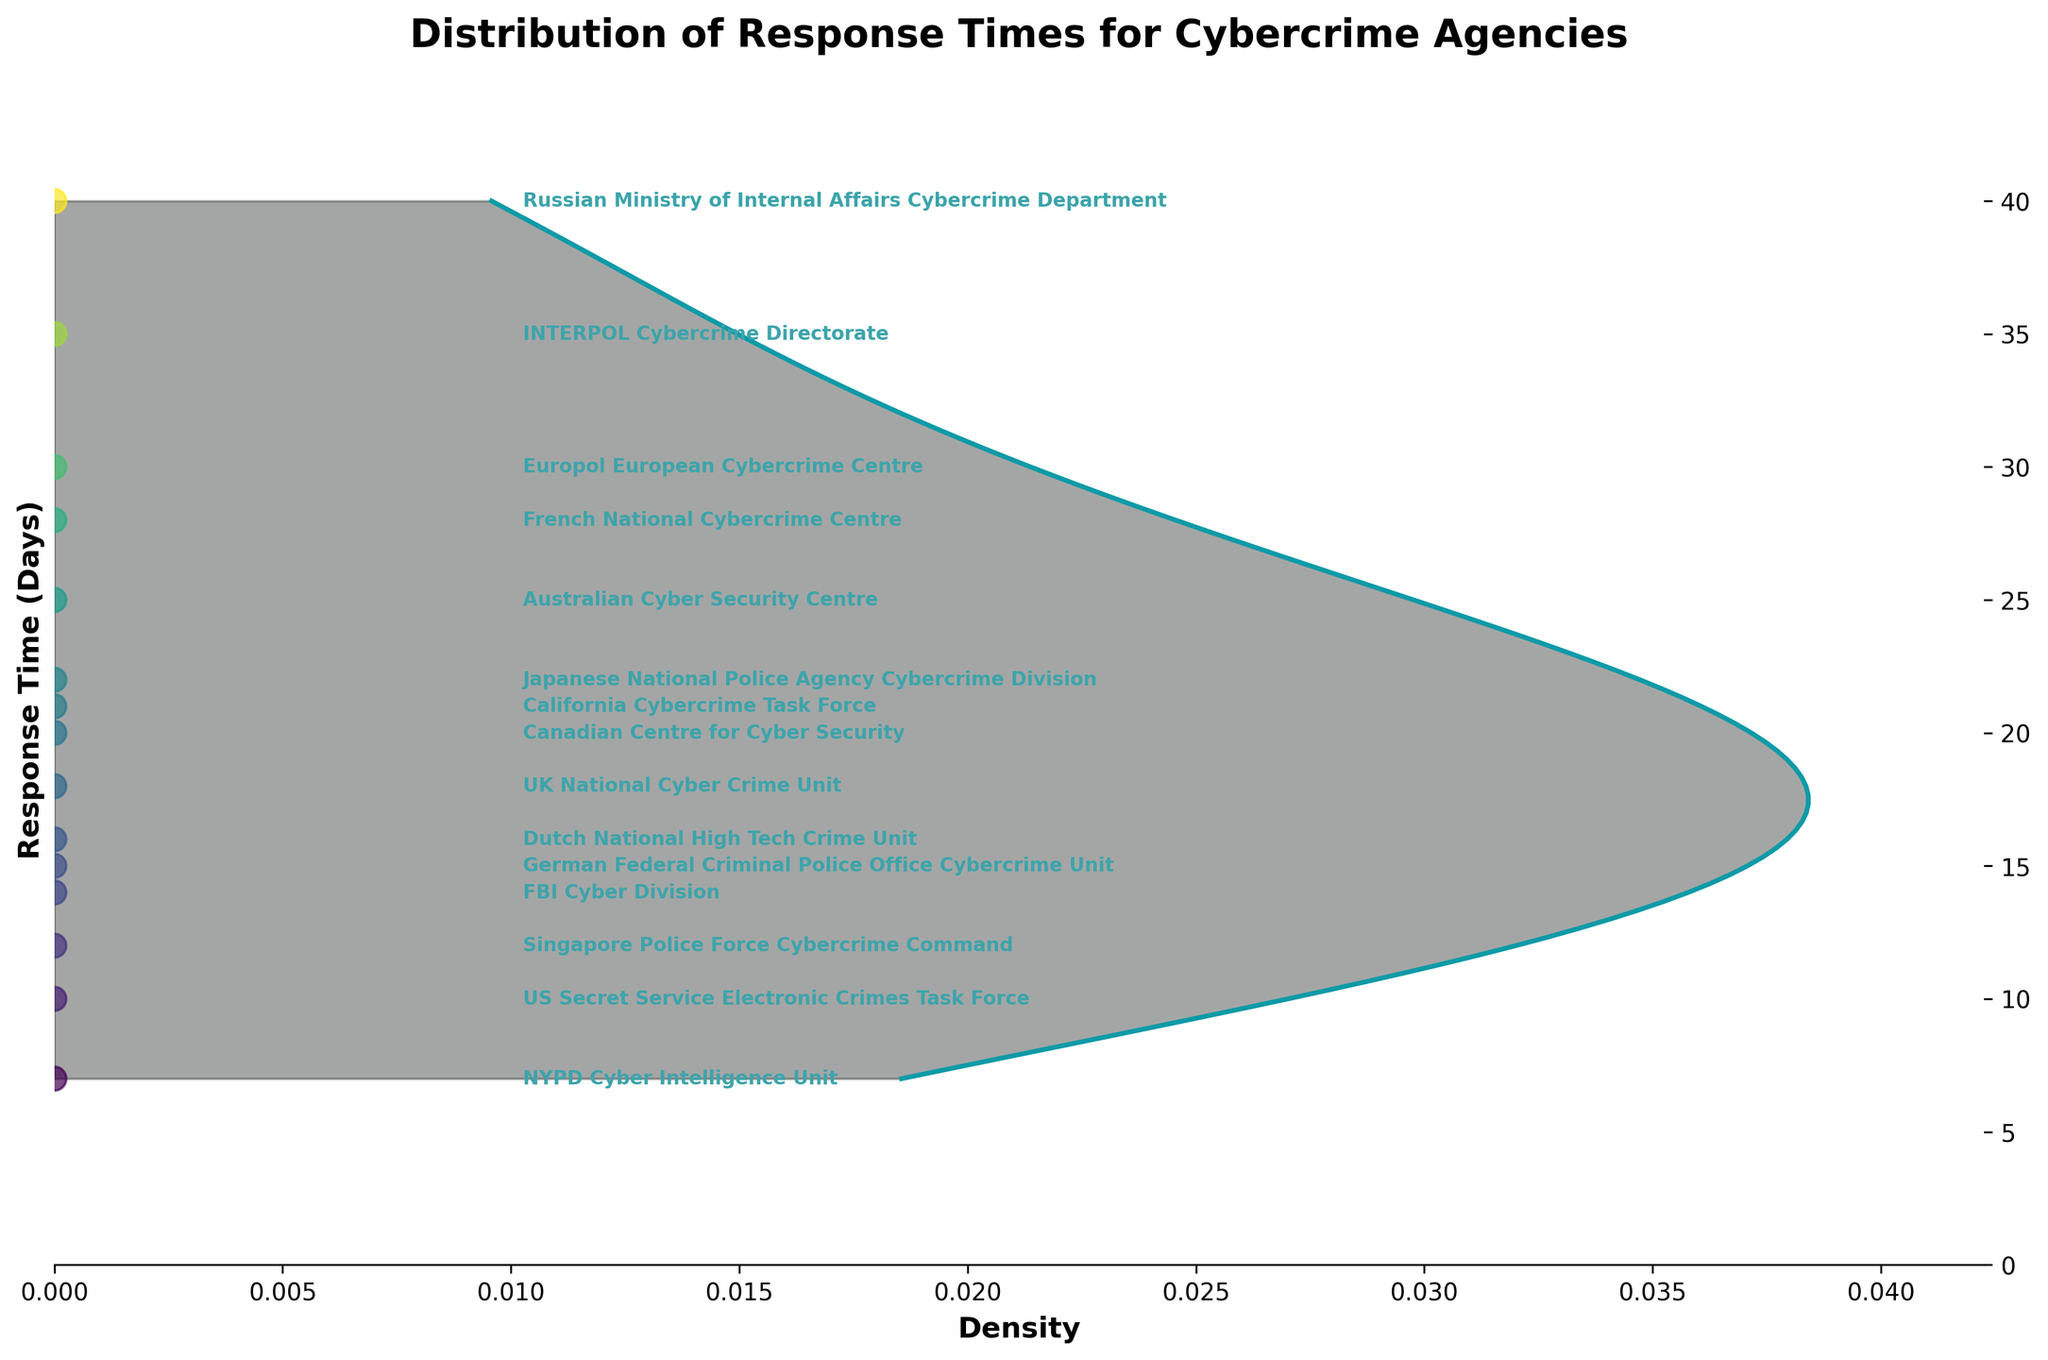What is the title of the plot? The title is usually displayed prominently at the top of the figure. It provides a summary of the information presented in the plot. Here, the title is clearly shown at the top.
Answer: Distribution of Response Times for Cybercrime Agencies How many data points are shown in the plot? The data points are represented by the scattered dots along the horizontal axis, corresponding to the response times of each law enforcement agency. Each agency has one data point. By counting the dots or agencies listed, we can determine the number of data points.
Answer: 15 Which agency has the longest response time, and what is it? The longest response time corresponds to the highest point on the vertical axis. The agency with its name annotated next to the highest point is the one with the longest response time.
Answer: Russian Ministry of Internal Affairs Cybercrime Department, 40 days Which two agencies have the closest response times? To find the closest response times, we need to identify two points that are closest to each other on the vertical axis. By visually inspecting the plot, we can find these two points.
Answer: FBI Cyber Division and German Federal Criminal Police Office Cybercrime Unit What is the average response time of all the agencies? To find the average response time, sum up all the response times and divide by the number of agencies. Response times: 14, 7, 21, 10, 30, 18, 25, 35, 15, 20, 12, 28, 16, 22, 40. Total sum: 313, number of agencies: 15, average response time: 313 / 15.
Answer: 20.87 days What is the range of the response times? The range is calculated by subtracting the smallest response time from the largest response time. The smallest response time is 7 days, and the largest response time is 40 days. Range: 40 - 7.
Answer: 33 days Which agency has the response time closest to the median value? First, we find the median response time by ordering the response times and finding the middle value. Ordered response times: 7, 10, 12, 14, 15, 16, 18, 20, 21, 22, 25, 28, 30, 35, 40. Median is the middle value: 20. The agency with this response time: Canadian Centre for Cyber Security.
Answer: Canadian Centre for Cyber Security What is the difference in response time between the fastest and the slowest agency? The fastest response time is 7 days, and the slowest response time is 40 days. The difference is calculated by subtracting the fastest response time from the slowest response time. Difference: 40 - 7.
Answer: 33 days Is the response time distribution skewed more towards longer or shorter response times? To determine the skewness, we observe the shape of the density plot. If it is skewed towards longer response times, more data points will be concentrated on the higher response times. The long tail on the right side indicates skewness towards longer response times.
Answer: Longer response times 